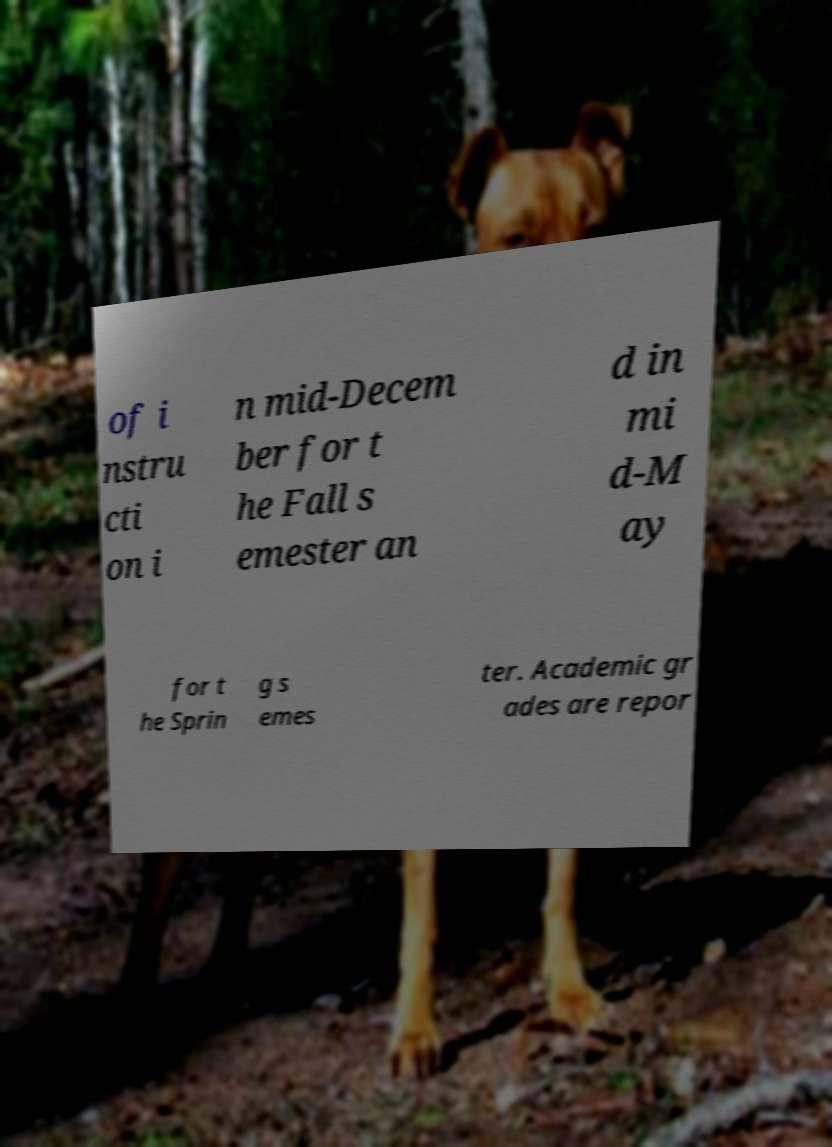Could you assist in decoding the text presented in this image and type it out clearly? of i nstru cti on i n mid-Decem ber for t he Fall s emester an d in mi d-M ay for t he Sprin g s emes ter. Academic gr ades are repor 